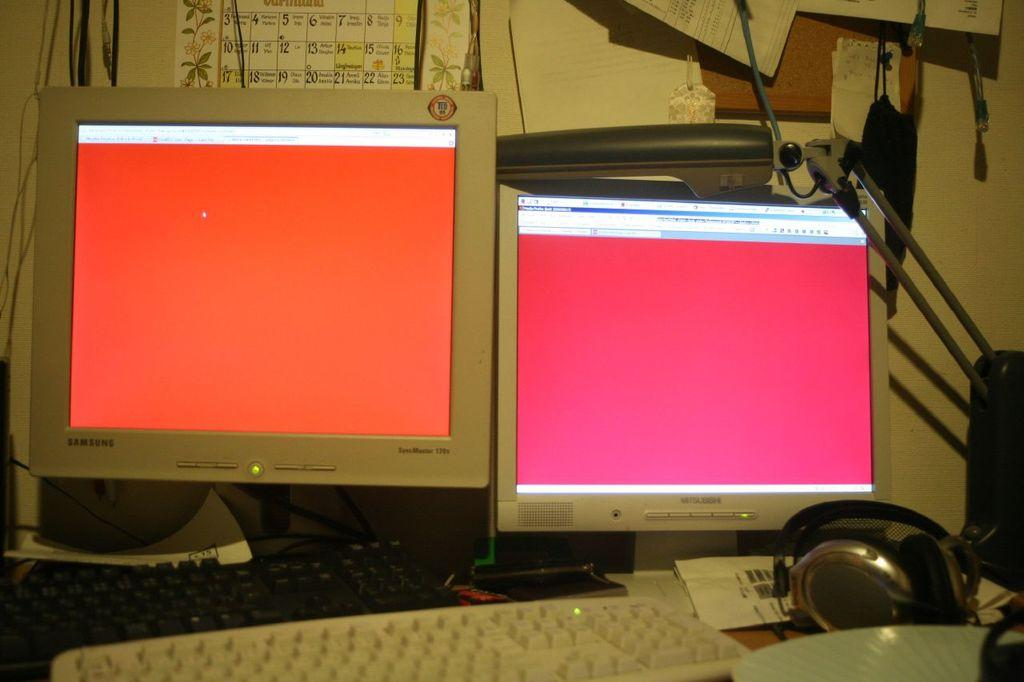<image>
Give a short and clear explanation of the subsequent image. Samsung and Mitsubishi monitors sit side by side on the desk. 